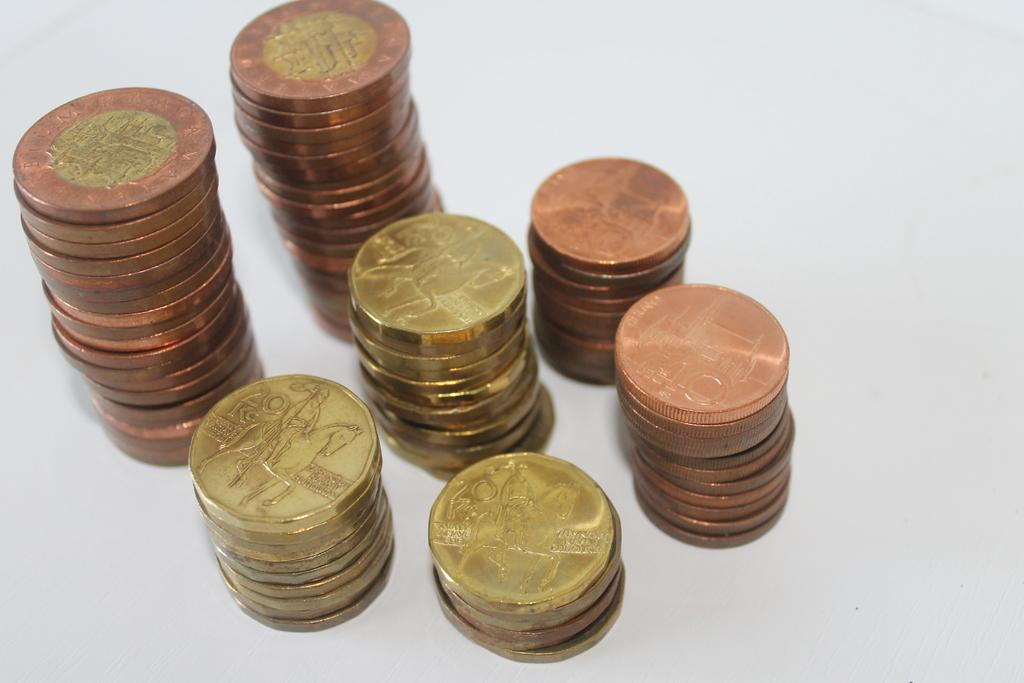<image>
Render a clear and concise summary of the photo. Several coins of different denominations are stacked together one with the number 20 on it 